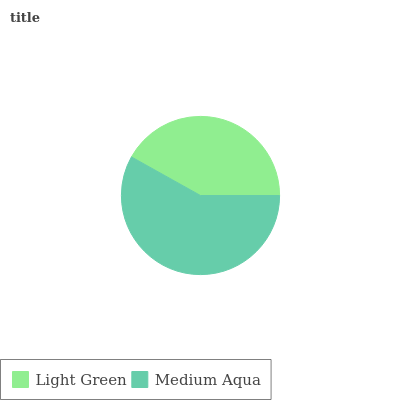Is Light Green the minimum?
Answer yes or no. Yes. Is Medium Aqua the maximum?
Answer yes or no. Yes. Is Medium Aqua the minimum?
Answer yes or no. No. Is Medium Aqua greater than Light Green?
Answer yes or no. Yes. Is Light Green less than Medium Aqua?
Answer yes or no. Yes. Is Light Green greater than Medium Aqua?
Answer yes or no. No. Is Medium Aqua less than Light Green?
Answer yes or no. No. Is Medium Aqua the high median?
Answer yes or no. Yes. Is Light Green the low median?
Answer yes or no. Yes. Is Light Green the high median?
Answer yes or no. No. Is Medium Aqua the low median?
Answer yes or no. No. 